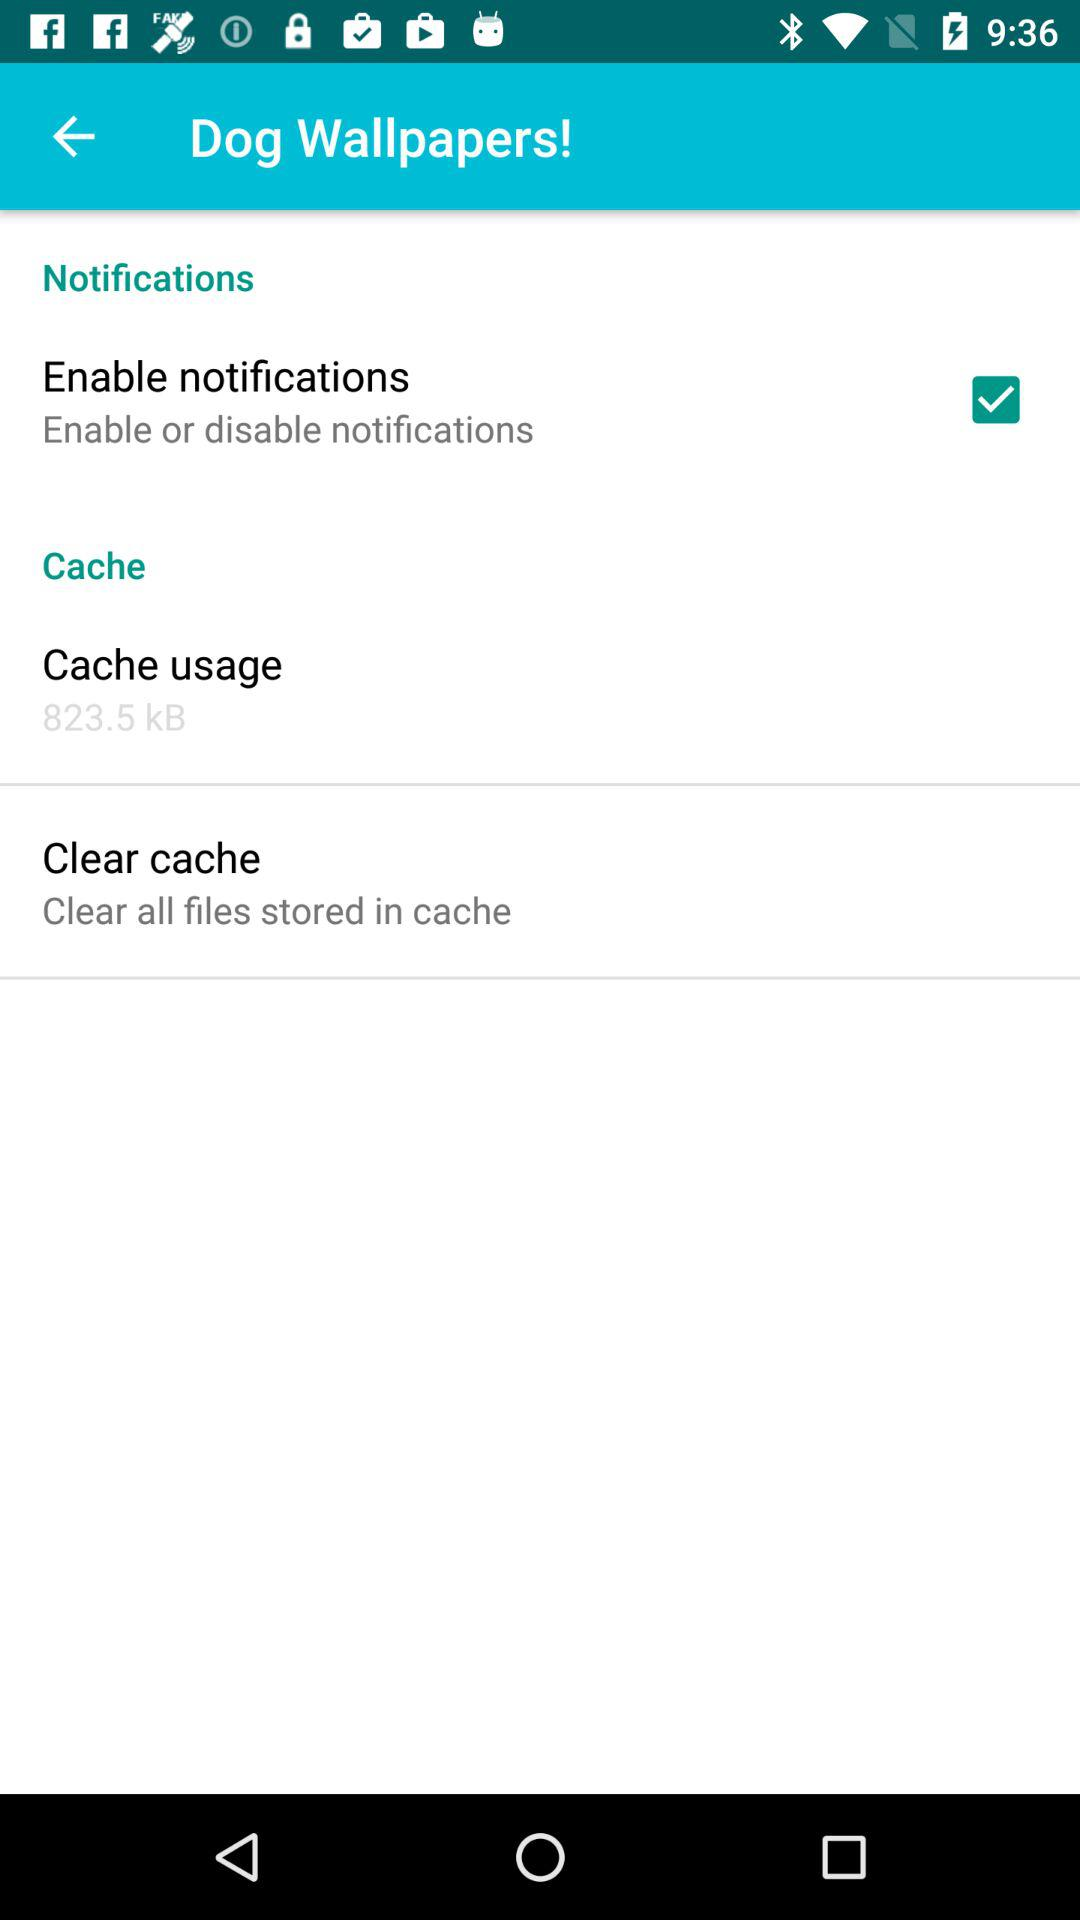How much cache is being used?
Answer the question using a single word or phrase. 823.5 kB 